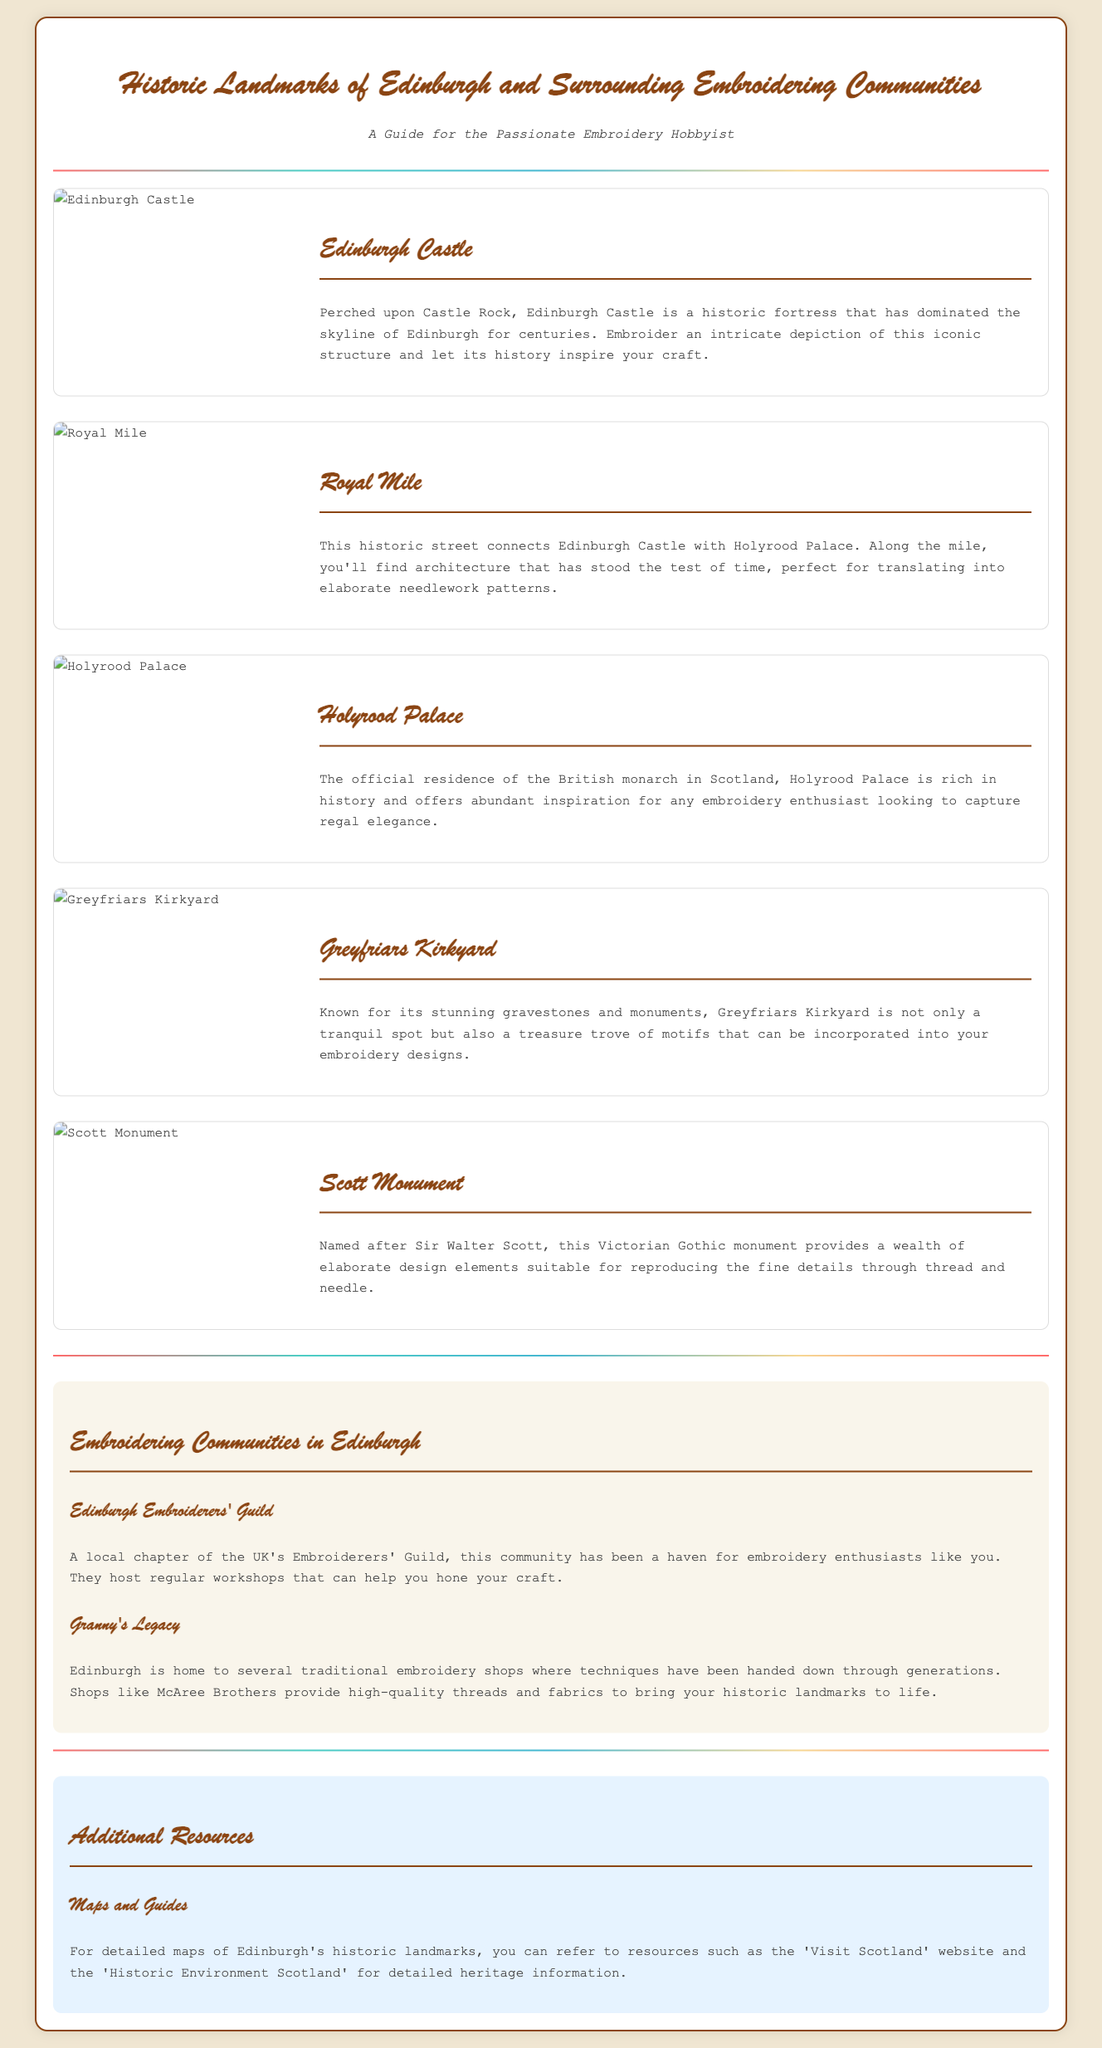What is the title of the document? The title of the document is prominently displayed at the top.
Answer: Historic Landmarks of Edinburgh and Surrounding Embroidering Communities How many landmarks are featured in the document? The number of landmarks can be counted from the sections listed in the document that describes each landmark.
Answer: Five What is the first landmark mentioned in the document? The first landmark is the one that is listed first in the sequence of landmarks in the document.
Answer: Edinburgh Castle Which organization is mentioned as a community for embroiderers? The community organization can be found in the section that describes the embroidering communities.
Answer: Edinburgh Embroiderers' Guild What motif can be found in Greyfriars Kirkyard? The motifs refer to the designs and inspirations that can be extracted from the description of Greyfriars Kirkyard.
Answer: Gravestones and monuments What type of workshops does the Edinburgh Embroiderers' Guild host? The type of workshops is specified in the description of the Edinburgh Embroiderers' Guild.
Answer: Regular workshops What is the purpose of the document? The purpose of the document can be inferred from its subtitle, which indicates its intended audience and content.
Answer: A guide for the passionate embroidery hobbyist What kind of resources does the document suggest for maps and guides? Resources are specifically mentioned in the section about additional resources in reference to finding detailed maps.
Answer: Visit Scotland and Historic Environment Scotland 